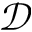Convert formula to latex. <formula><loc_0><loc_0><loc_500><loc_500>\mathcal { D }</formula> 